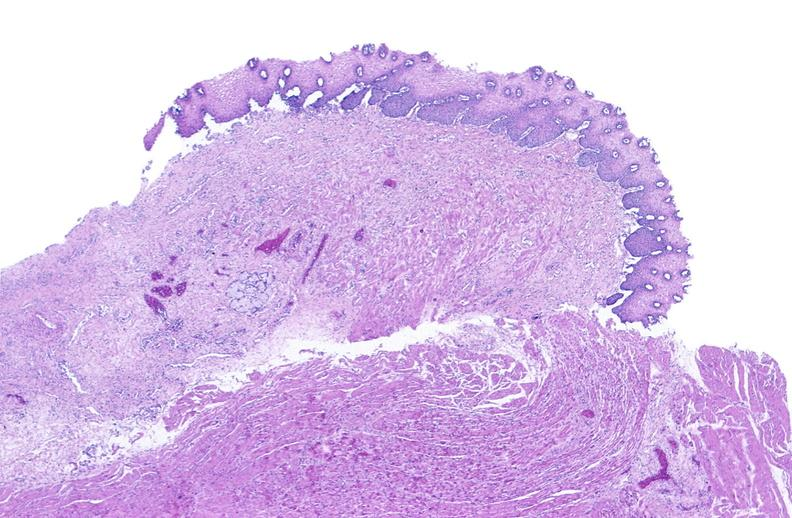where is this from?
Answer the question using a single word or phrase. Gastrointestinal system 